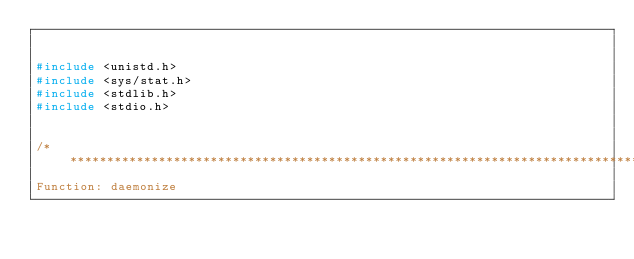Convert code to text. <code><loc_0><loc_0><loc_500><loc_500><_C++_>

#include <unistd.h>
#include <sys/stat.h>
#include <stdlib.h>
#include <stdio.h>


/*******************************************************************************
Function: daemonize</code> 